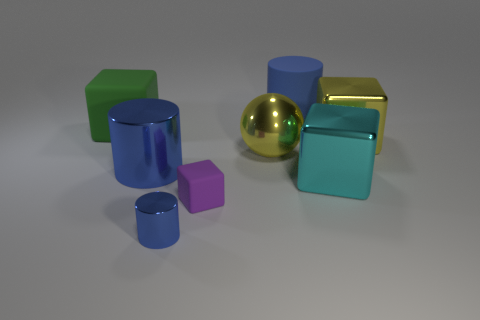What materials do the objects seem to be made of? The objects appear to be rendered with different materials. The cubes and cylinders exhibit matte finishes suggestive of painted metal or plastic, while the golden sphere and the reflective cube seem to have a metallic finish, implying they could be made of polished metal or a material with a similar reflective quality. 